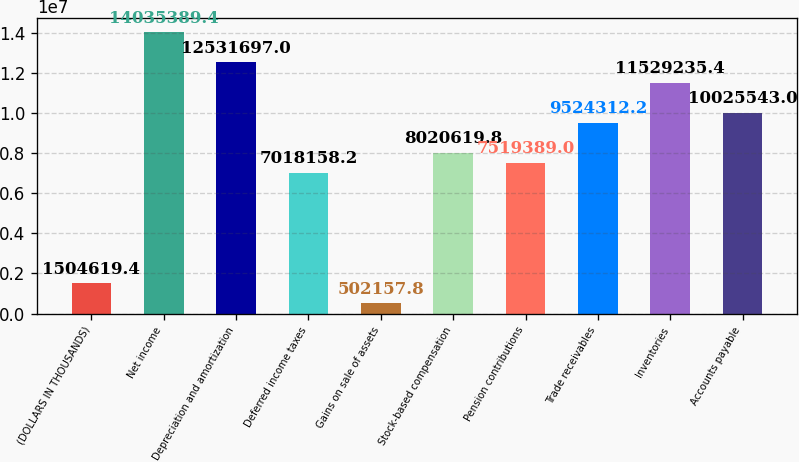Convert chart. <chart><loc_0><loc_0><loc_500><loc_500><bar_chart><fcel>(DOLLARS IN THOUSANDS)<fcel>Net income<fcel>Depreciation and amortization<fcel>Deferred income taxes<fcel>Gains on sale of assets<fcel>Stock-based compensation<fcel>Pension contributions<fcel>Trade receivables<fcel>Inventories<fcel>Accounts payable<nl><fcel>1.50462e+06<fcel>1.40354e+07<fcel>1.25317e+07<fcel>7.01816e+06<fcel>502158<fcel>8.02062e+06<fcel>7.51939e+06<fcel>9.52431e+06<fcel>1.15292e+07<fcel>1.00255e+07<nl></chart> 